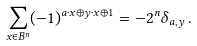<formula> <loc_0><loc_0><loc_500><loc_500>\sum _ { x \in B ^ { n } } ( - 1 ) ^ { a \cdot x \oplus y \cdot x \oplus 1 } = - 2 ^ { n } \delta _ { a , y } \, .</formula> 